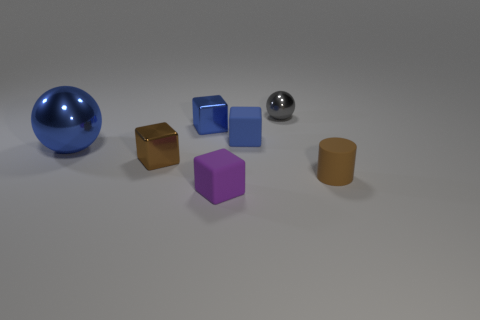Can you describe the textures of the objects in the image? Certainly! The objects exhibit a variety of textures: the sphere has a glossy finish, reflecting light sharply. The cube and the cylinder have a matte surface, diffusing light softly, while the small sphere has a metallic sheen, giving it a mirror-like quality. Which object stands out the most to you? The large blue sphere stands out due to its vibrant color, larger size, and reflective surface, which draws the eye in contrast to the other more subdued objects. 